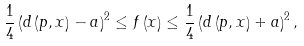<formula> <loc_0><loc_0><loc_500><loc_500>\frac { 1 } { 4 } \left ( d \left ( p , x \right ) - a \right ) ^ { 2 } \leq f \left ( x \right ) \leq \frac { 1 } { 4 } \left ( d \left ( p , x \right ) + a \right ) ^ { 2 } ,</formula> 